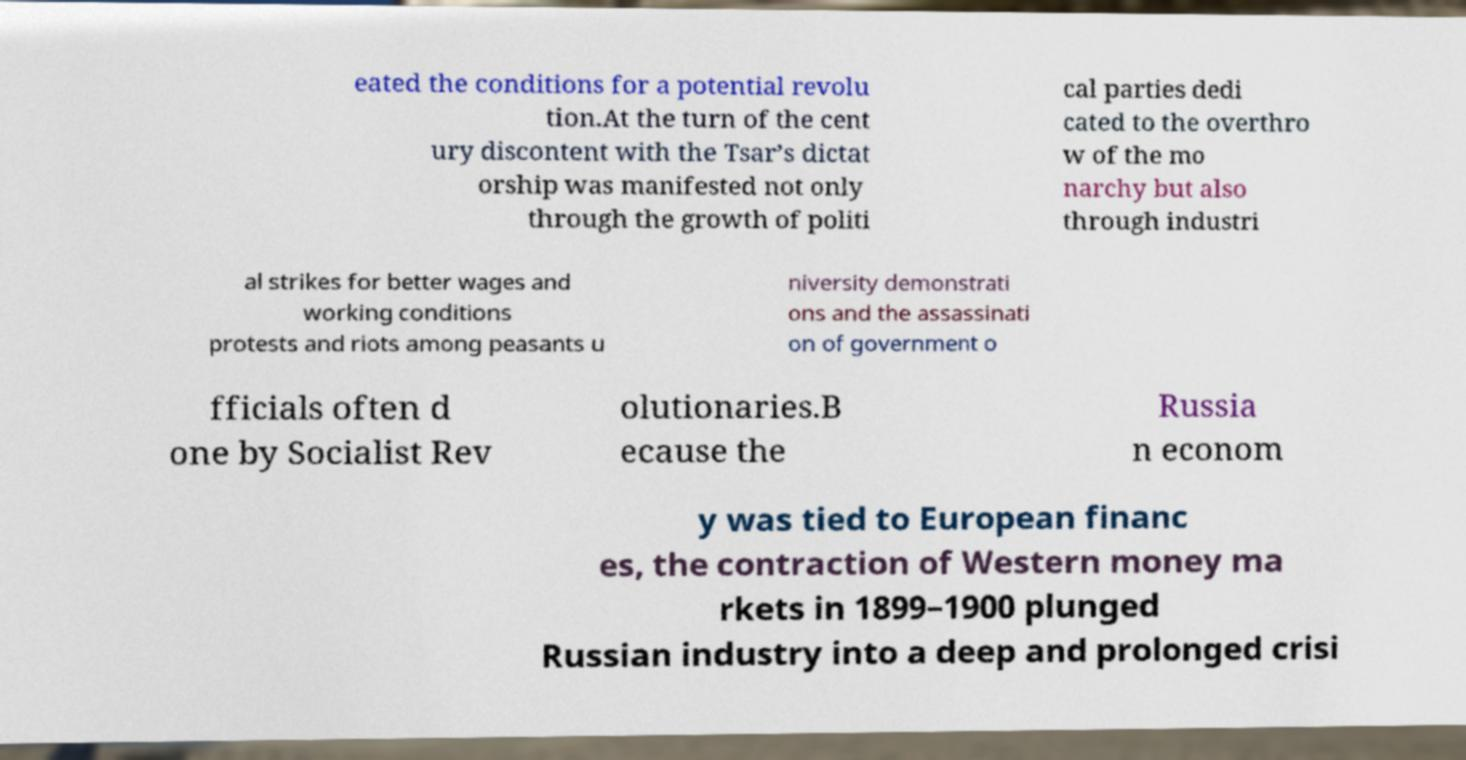Could you assist in decoding the text presented in this image and type it out clearly? eated the conditions for a potential revolu tion.At the turn of the cent ury discontent with the Tsar’s dictat orship was manifested not only through the growth of politi cal parties dedi cated to the overthro w of the mo narchy but also through industri al strikes for better wages and working conditions protests and riots among peasants u niversity demonstrati ons and the assassinati on of government o fficials often d one by Socialist Rev olutionaries.B ecause the Russia n econom y was tied to European financ es, the contraction of Western money ma rkets in 1899–1900 plunged Russian industry into a deep and prolonged crisi 